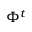<formula> <loc_0><loc_0><loc_500><loc_500>\Phi ^ { t }</formula> 